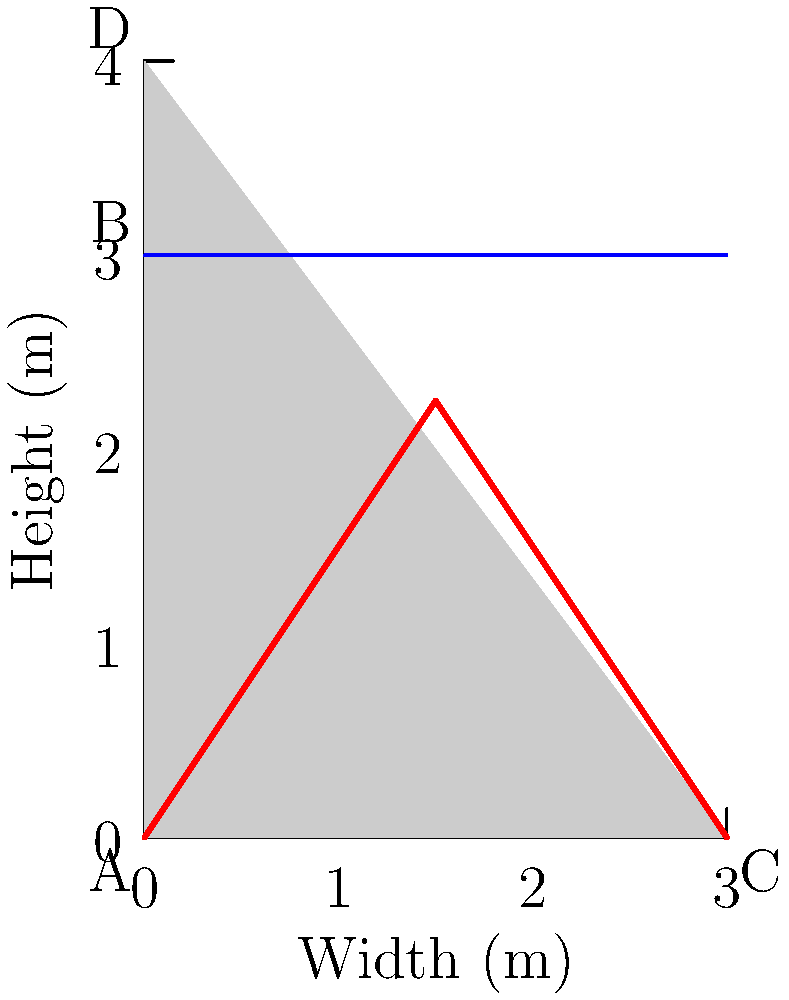In the dam cross-section shown, where the water level reaches point B, how would you describe the pressure distribution along the face of the dam? As a cinematographer familiar with creating visual effects for action scenes involving dams, how might this information influence your approach to filming or creating CGI for such a scene? To understand the pressure distribution in the dam cross-section:

1. Water pressure increases linearly with depth due to the weight of the water above.

2. At the water surface (point B), the pressure is atmospheric (effectively zero for this analysis).

3. The pressure at any point below the surface is given by the equation:

   $$P = \rho g h$$

   where $P$ is pressure, $\rho$ is water density, $g$ is gravitational acceleration, and $h$ is depth below the surface.

4. The maximum pressure occurs at the base of the dam (point A), where the depth is greatest.

5. The pressure distribution forms a triangular shape (shown in red) because it increases linearly from zero at the surface to maximum at the base.

6. The resultant force acts at 1/3 of the height from the base, which is important for structural calculations.

For a cinematographer:

1. This knowledge can inform the creation of realistic water effects, especially in scenes depicting dam failures or water breaches.

2. Understanding the pressure distribution helps in visualizing and creating accurate CGI for water flow patterns and intensities during action sequences.

3. It can guide camera placement for dramatic shots, focusing on areas of highest pressure (near the base) for maximum impact in failure scenarios.

4. This information can assist in collaborating with special effects teams to ensure scientifically accurate representations of water behavior in high-pressure situations.
Answer: Triangular distribution, increasing linearly from zero at the water surface to maximum at the base. 